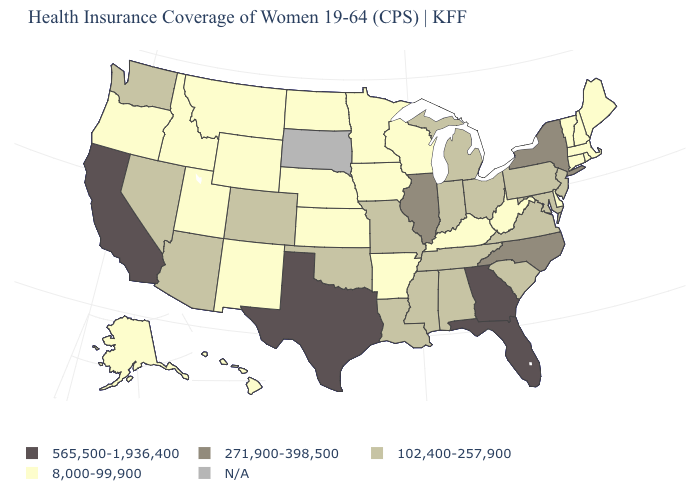Does Wisconsin have the lowest value in the MidWest?
Quick response, please. Yes. Among the states that border Maryland , which have the highest value?
Be succinct. Pennsylvania, Virginia. What is the value of Oklahoma?
Short answer required. 102,400-257,900. What is the value of Nevada?
Short answer required. 102,400-257,900. Is the legend a continuous bar?
Quick response, please. No. Which states have the highest value in the USA?
Concise answer only. California, Florida, Georgia, Texas. What is the highest value in the West ?
Concise answer only. 565,500-1,936,400. What is the lowest value in the South?
Quick response, please. 8,000-99,900. What is the lowest value in the West?
Concise answer only. 8,000-99,900. Which states have the lowest value in the MidWest?
Answer briefly. Iowa, Kansas, Minnesota, Nebraska, North Dakota, Wisconsin. Which states hav the highest value in the MidWest?
Answer briefly. Illinois. Name the states that have a value in the range 565,500-1,936,400?
Be succinct. California, Florida, Georgia, Texas. Among the states that border Colorado , which have the lowest value?
Keep it brief. Kansas, Nebraska, New Mexico, Utah, Wyoming. Does Washington have the highest value in the USA?
Quick response, please. No. What is the value of Vermont?
Be succinct. 8,000-99,900. 